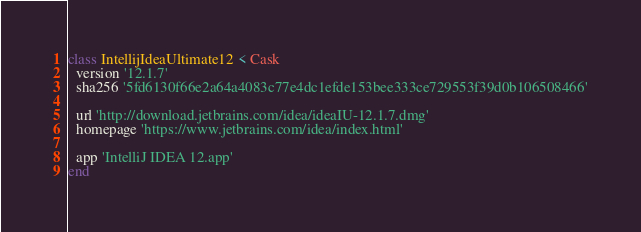<code> <loc_0><loc_0><loc_500><loc_500><_Ruby_>class IntellijIdeaUltimate12 < Cask
  version '12.1.7'
  sha256 '5fd6130f66e2a64a4083c77e4dc1efde153bee333ce729553f39d0b106508466'

  url 'http://download.jetbrains.com/idea/ideaIU-12.1.7.dmg'
  homepage 'https://www.jetbrains.com/idea/index.html'

  app 'IntelliJ IDEA 12.app'
end
</code> 